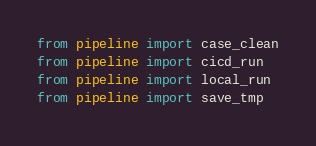<code> <loc_0><loc_0><loc_500><loc_500><_Python_>from pipeline import case_clean
from pipeline import cicd_run
from pipeline import local_run
from pipeline import save_tmp</code> 